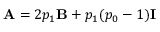<formula> <loc_0><loc_0><loc_500><loc_500>A = 2 p _ { 1 } B + p _ { 1 } ( p _ { 0 } - 1 ) I</formula> 